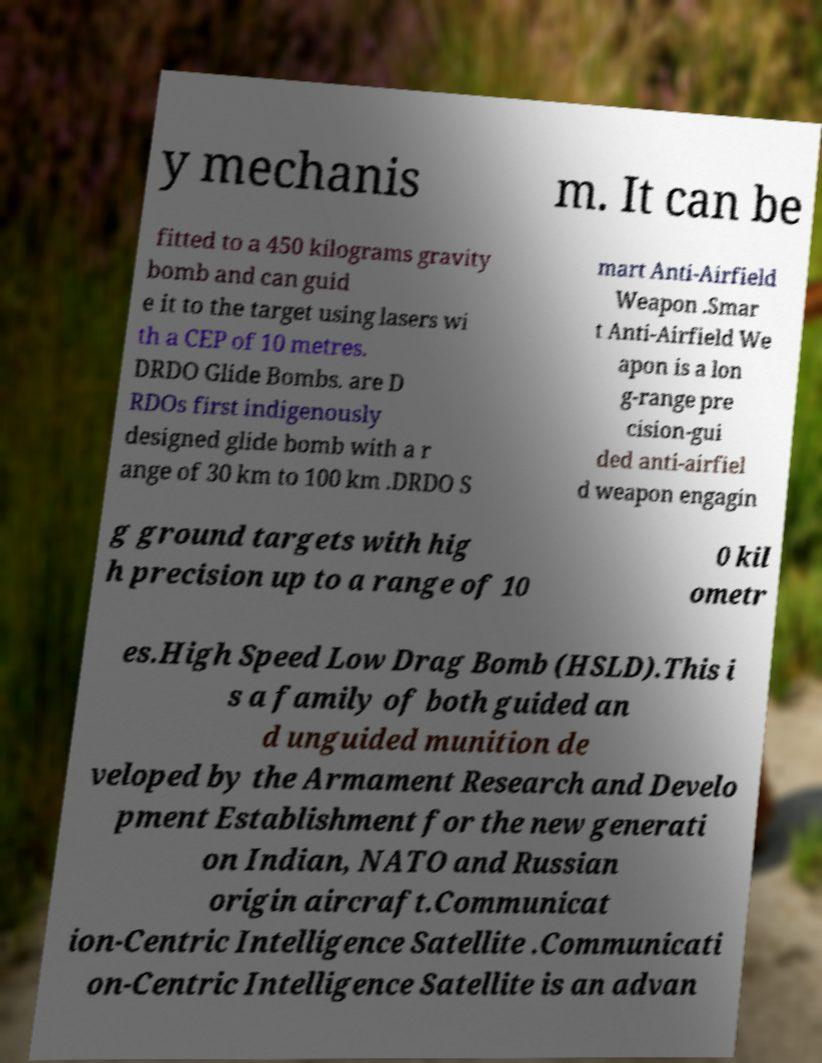Please identify and transcribe the text found in this image. y mechanis m. It can be fitted to a 450 kilograms gravity bomb and can guid e it to the target using lasers wi th a CEP of 10 metres. DRDO Glide Bombs. are D RDOs first indigenously designed glide bomb with a r ange of 30 km to 100 km .DRDO S mart Anti-Airfield Weapon .Smar t Anti-Airfield We apon is a lon g-range pre cision-gui ded anti-airfiel d weapon engagin g ground targets with hig h precision up to a range of 10 0 kil ometr es.High Speed Low Drag Bomb (HSLD).This i s a family of both guided an d unguided munition de veloped by the Armament Research and Develo pment Establishment for the new generati on Indian, NATO and Russian origin aircraft.Communicat ion-Centric Intelligence Satellite .Communicati on-Centric Intelligence Satellite is an advan 